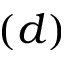<formula> <loc_0><loc_0><loc_500><loc_500>( d )</formula> 